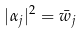<formula> <loc_0><loc_0><loc_500><loc_500>| \alpha _ { j } | ^ { 2 } = \bar { w } _ { j }</formula> 